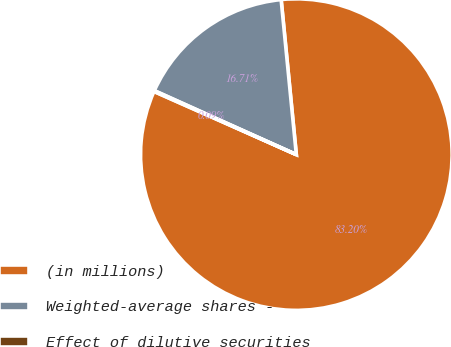<chart> <loc_0><loc_0><loc_500><loc_500><pie_chart><fcel>(in millions)<fcel>Weighted-average shares -<fcel>Effect of dilutive securities<nl><fcel>83.2%<fcel>16.71%<fcel>0.09%<nl></chart> 